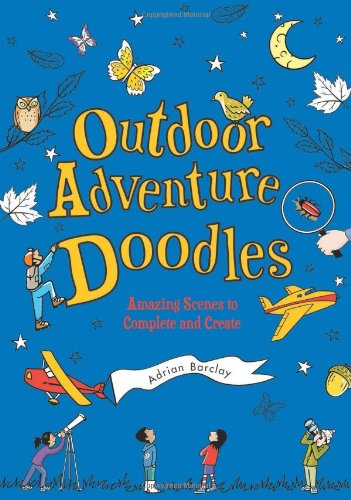What is the title of this book? The title of the book featured in the image is 'Outdoor Adventure Doodles: Amazing Scenes to Complete and Create,' which invites young readers into interactive and imaginative outdoor-themed activities. 